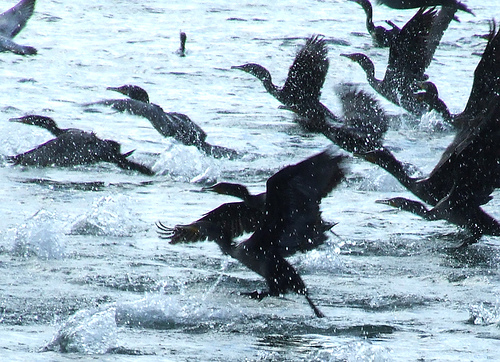Please provide the bounding box coordinate of the region this sentence describes: a duck frantically flapping it's wings. The bounding box coordinates for the region describing 'a duck frantically flapping its wings' are [0.61, 0.33, 0.81, 0.49]. This area captures the dynamic movement and energy of the bird's wing activity. 